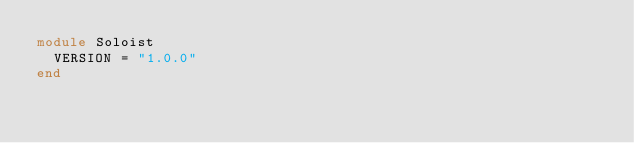<code> <loc_0><loc_0><loc_500><loc_500><_Ruby_>module Soloist
  VERSION = "1.0.0"
end
</code> 